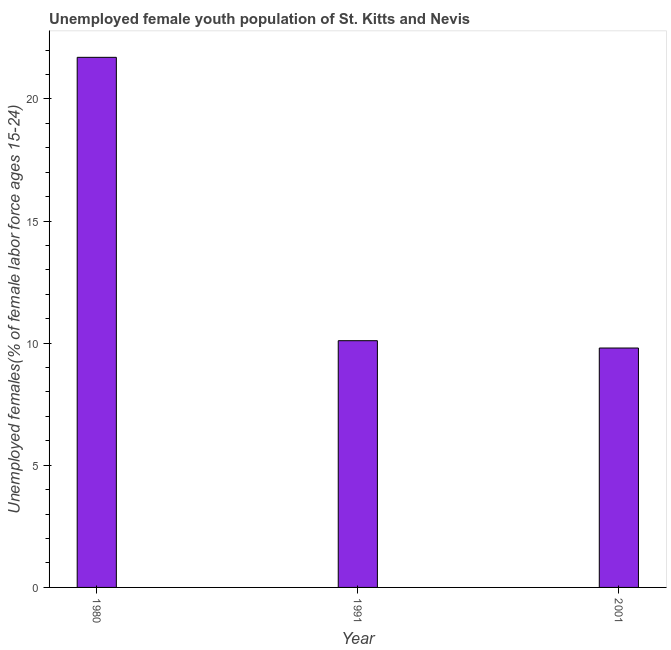Does the graph contain any zero values?
Make the answer very short. No. Does the graph contain grids?
Give a very brief answer. No. What is the title of the graph?
Your answer should be very brief. Unemployed female youth population of St. Kitts and Nevis. What is the label or title of the X-axis?
Your answer should be compact. Year. What is the label or title of the Y-axis?
Give a very brief answer. Unemployed females(% of female labor force ages 15-24). What is the unemployed female youth in 2001?
Your response must be concise. 9.8. Across all years, what is the maximum unemployed female youth?
Make the answer very short. 21.7. Across all years, what is the minimum unemployed female youth?
Offer a terse response. 9.8. In which year was the unemployed female youth maximum?
Make the answer very short. 1980. In which year was the unemployed female youth minimum?
Offer a terse response. 2001. What is the sum of the unemployed female youth?
Your answer should be compact. 41.6. What is the difference between the unemployed female youth in 1980 and 2001?
Make the answer very short. 11.9. What is the average unemployed female youth per year?
Provide a short and direct response. 13.87. What is the median unemployed female youth?
Offer a very short reply. 10.1. What is the ratio of the unemployed female youth in 1980 to that in 2001?
Your response must be concise. 2.21. What is the difference between the highest and the lowest unemployed female youth?
Ensure brevity in your answer.  11.9. In how many years, is the unemployed female youth greater than the average unemployed female youth taken over all years?
Provide a succinct answer. 1. How many bars are there?
Keep it short and to the point. 3. How many years are there in the graph?
Your response must be concise. 3. What is the difference between two consecutive major ticks on the Y-axis?
Your response must be concise. 5. What is the Unemployed females(% of female labor force ages 15-24) of 1980?
Make the answer very short. 21.7. What is the Unemployed females(% of female labor force ages 15-24) of 1991?
Provide a succinct answer. 10.1. What is the Unemployed females(% of female labor force ages 15-24) of 2001?
Your response must be concise. 9.8. What is the difference between the Unemployed females(% of female labor force ages 15-24) in 1980 and 1991?
Ensure brevity in your answer.  11.6. What is the difference between the Unemployed females(% of female labor force ages 15-24) in 1991 and 2001?
Make the answer very short. 0.3. What is the ratio of the Unemployed females(% of female labor force ages 15-24) in 1980 to that in 1991?
Offer a terse response. 2.15. What is the ratio of the Unemployed females(% of female labor force ages 15-24) in 1980 to that in 2001?
Make the answer very short. 2.21. What is the ratio of the Unemployed females(% of female labor force ages 15-24) in 1991 to that in 2001?
Offer a terse response. 1.03. 